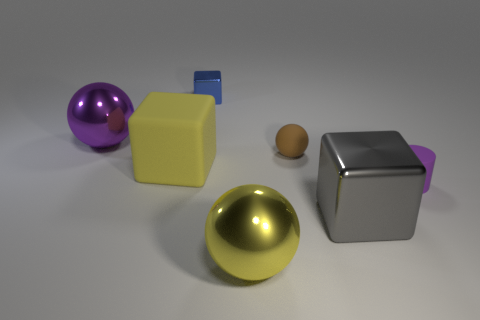Subtract all brown blocks. Subtract all yellow spheres. How many blocks are left? 3 Add 1 gray metal objects. How many objects exist? 8 Subtract all cylinders. How many objects are left? 6 Subtract 0 brown cubes. How many objects are left? 7 Subtract all big yellow rubber blocks. Subtract all blue objects. How many objects are left? 5 Add 4 small blue metal blocks. How many small blue metal blocks are left? 5 Add 5 cyan shiny cubes. How many cyan shiny cubes exist? 5 